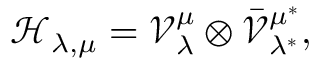<formula> <loc_0><loc_0><loc_500><loc_500>\mathcal { H } _ { \lambda , \mu } = \mathcal { V } _ { \lambda } ^ { \mu } \otimes \bar { \mathcal { V } } _ { \lambda ^ { * } } ^ { \mu ^ { * } } ,</formula> 